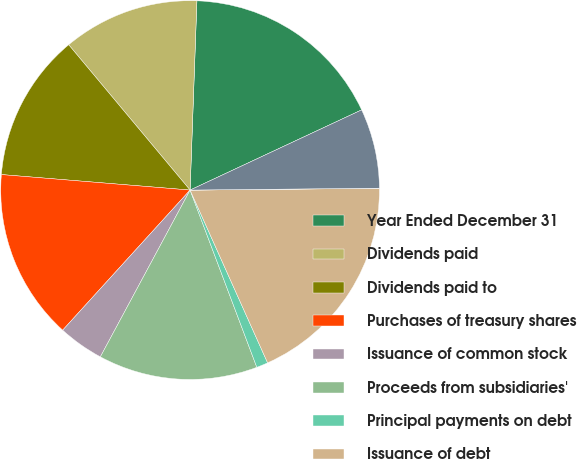<chart> <loc_0><loc_0><loc_500><loc_500><pie_chart><fcel>Year Ended December 31<fcel>Dividends paid<fcel>Dividends paid to<fcel>Purchases of treasury shares<fcel>Issuance of common stock<fcel>Proceeds from subsidiaries'<fcel>Principal payments on debt<fcel>Issuance of debt<fcel>Receipts of investment<fcel>Return of investment contract<nl><fcel>17.47%<fcel>11.65%<fcel>12.62%<fcel>14.56%<fcel>3.89%<fcel>13.59%<fcel>0.98%<fcel>18.44%<fcel>0.01%<fcel>6.8%<nl></chart> 